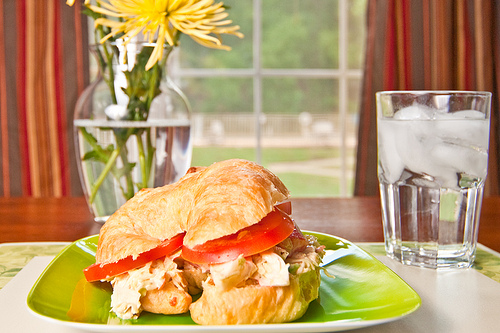Imagine if the setting was a part of a magical story. What would the story be about? In a distant land, there was a magical garden where every meal prepared was imbued with special powers. The croissant sandwich on the green plate was no ordinary meal—it had the power to grant the eater the ability to commune with nature. The glass of water? It was enchanted, ensuring anyone drinking from it would always tell the truth. The yellow flowers in the vase signaled harmony and peace, blooming eternally regardless of the season. One day, a curious young adventurer stumbled upon this garden, and with every bite and sip, they unlocked secrets of the natural world, learning to wield the elements and communicate with forest creatures. Their journey led them to become guardians of the enchanted garden, ensuring its magic was not misused and that balance was maintained in the realm. 